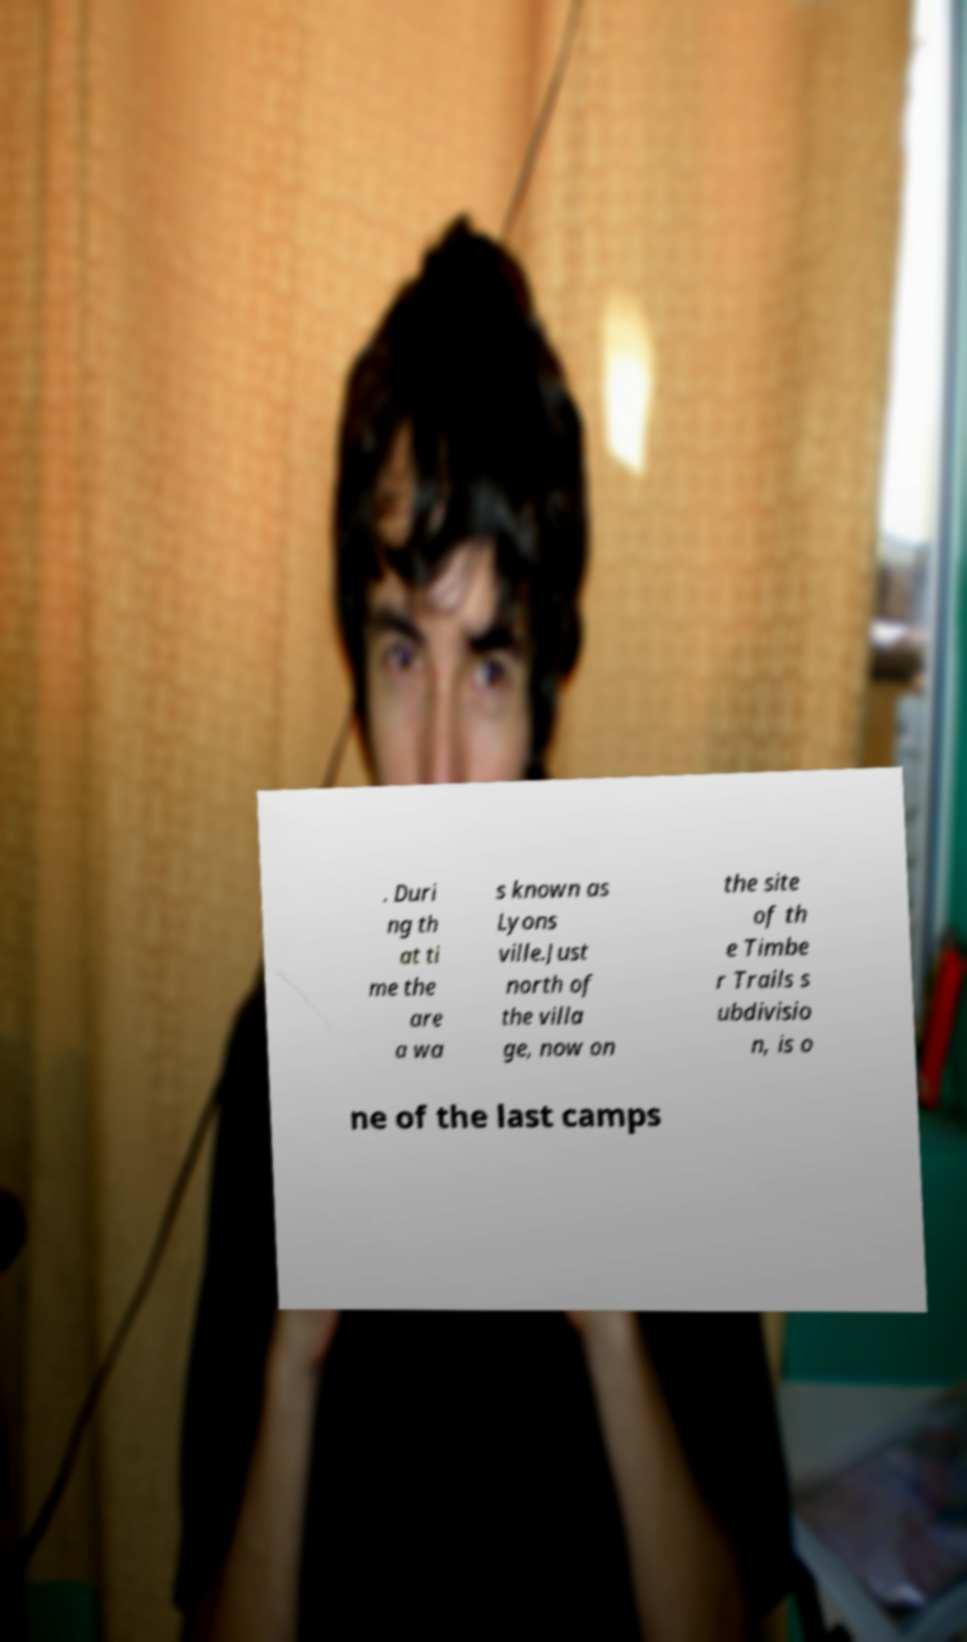For documentation purposes, I need the text within this image transcribed. Could you provide that? . Duri ng th at ti me the are a wa s known as Lyons ville.Just north of the villa ge, now on the site of th e Timbe r Trails s ubdivisio n, is o ne of the last camps 